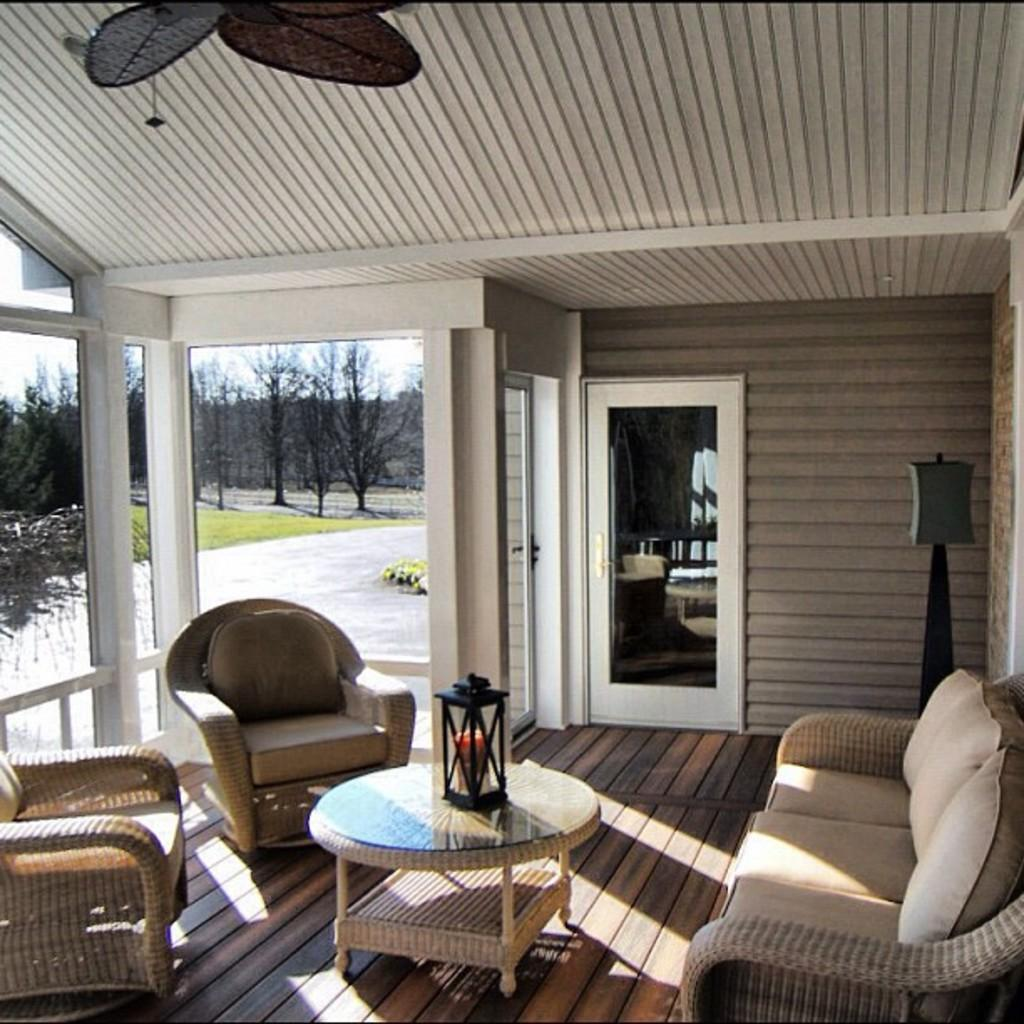What type of furniture is present in the image? There is a table and a sofa in the image. What is the source of light in the image? There is a lamp in the image. What can be seen in the background of the image? There is a door and a glass window in the background of the image. What is visible through the window? Trees are visible through the window. How many eyes can be seen on the sofa in the image? There are no eyes visible on the sofa in the image, as it is an inanimate object. 